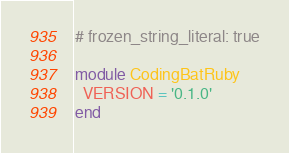<code> <loc_0><loc_0><loc_500><loc_500><_Ruby_># frozen_string_literal: true

module CodingBatRuby
  VERSION = '0.1.0'
end
</code> 